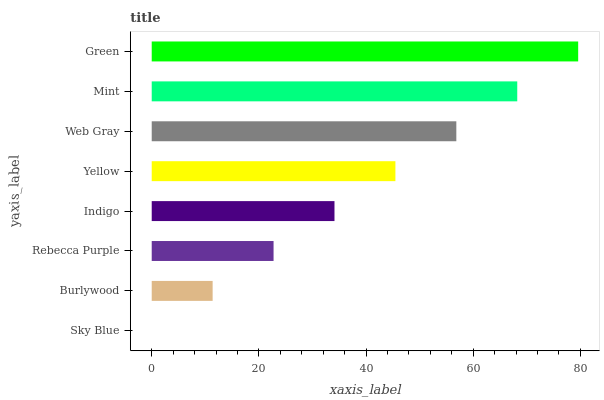Is Sky Blue the minimum?
Answer yes or no. Yes. Is Green the maximum?
Answer yes or no. Yes. Is Burlywood the minimum?
Answer yes or no. No. Is Burlywood the maximum?
Answer yes or no. No. Is Burlywood greater than Sky Blue?
Answer yes or no. Yes. Is Sky Blue less than Burlywood?
Answer yes or no. Yes. Is Sky Blue greater than Burlywood?
Answer yes or no. No. Is Burlywood less than Sky Blue?
Answer yes or no. No. Is Yellow the high median?
Answer yes or no. Yes. Is Indigo the low median?
Answer yes or no. Yes. Is Sky Blue the high median?
Answer yes or no. No. Is Sky Blue the low median?
Answer yes or no. No. 